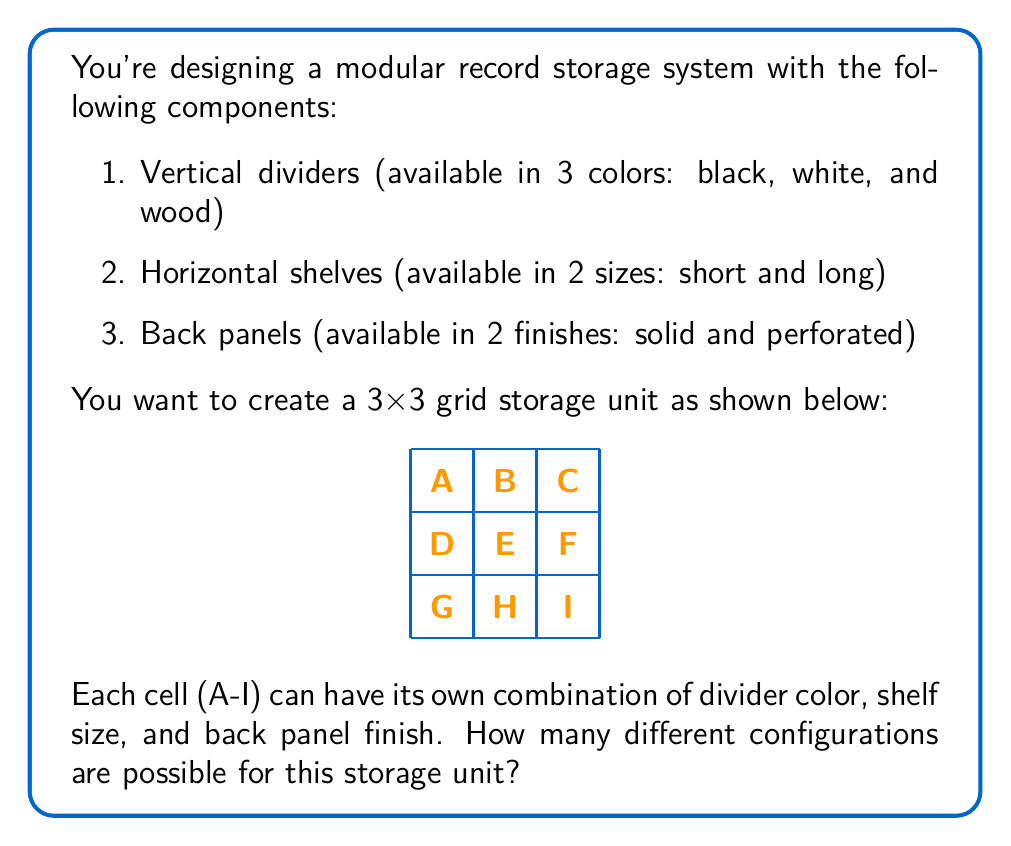Provide a solution to this math problem. Let's approach this step-by-step:

1) For each cell, we need to choose:
   - 1 of 3 divider colors
   - 1 of 2 shelf sizes
   - 1 of 2 back panel finishes

2) The number of choices for each cell is:
   $3 \times 2 \times 2 = 12$ combinations

3) We have 9 cells in total (A through I), and each cell can be configured independently.

4) According to the multiplication principle, when we have independent choices, we multiply the number of possibilities for each choice.

5) Therefore, the total number of configurations is:
   $12^9 = (3 \times 2 \times 2)^9$

6) Let's calculate this:
   $12^9 = 12 \times 12 \times 12 \times 12 \times 12 \times 12 \times 12 \times 12 \times 12$
   $= 68,719,476,736$

Thus, there are 68,719,476,736 possible configurations for this modular record storage system.
Answer: $$68,719,476,736$$ 